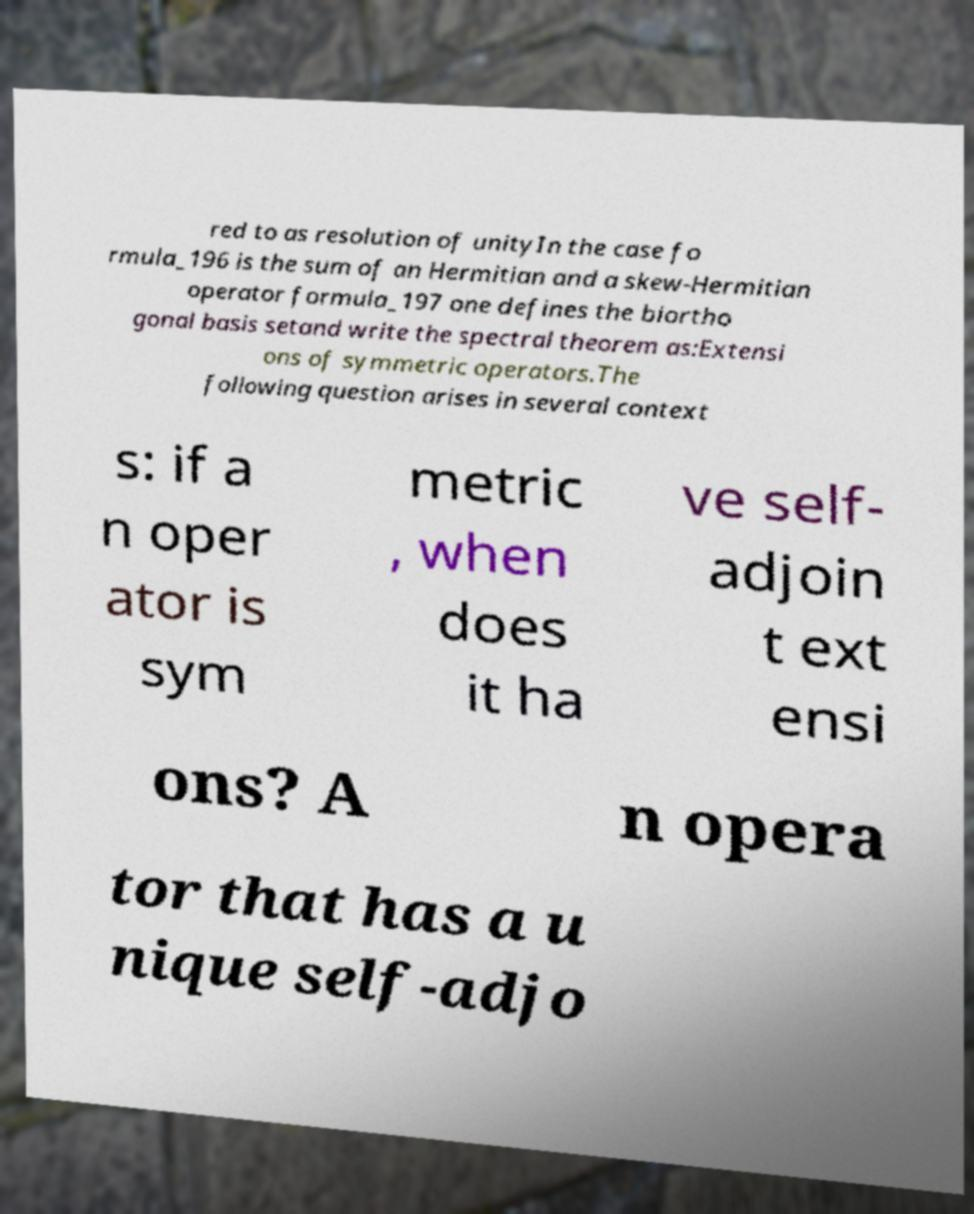What messages or text are displayed in this image? I need them in a readable, typed format. red to as resolution of unityIn the case fo rmula_196 is the sum of an Hermitian and a skew-Hermitian operator formula_197 one defines the biortho gonal basis setand write the spectral theorem as:Extensi ons of symmetric operators.The following question arises in several context s: if a n oper ator is sym metric , when does it ha ve self- adjoin t ext ensi ons? A n opera tor that has a u nique self-adjo 